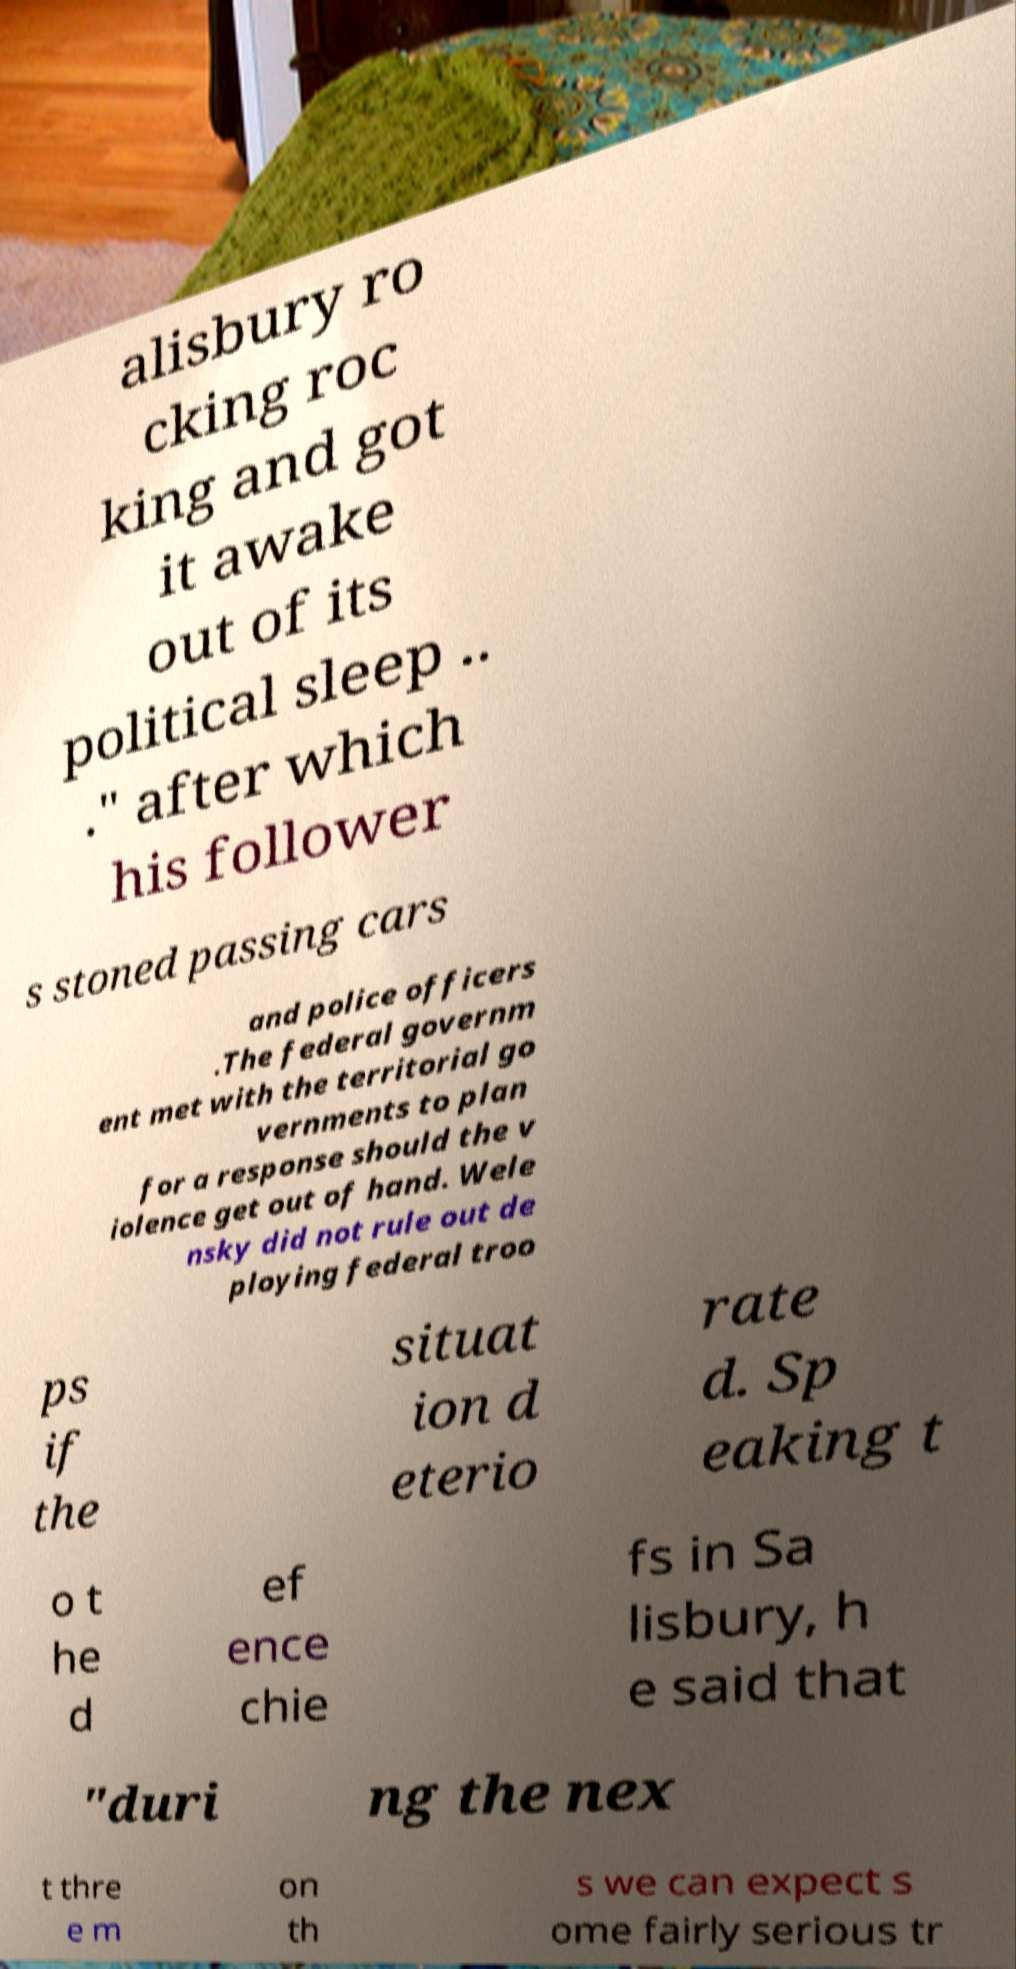Please read and relay the text visible in this image. What does it say? alisbury ro cking roc king and got it awake out of its political sleep .. ." after which his follower s stoned passing cars and police officers .The federal governm ent met with the territorial go vernments to plan for a response should the v iolence get out of hand. Wele nsky did not rule out de ploying federal troo ps if the situat ion d eterio rate d. Sp eaking t o t he d ef ence chie fs in Sa lisbury, h e said that "duri ng the nex t thre e m on th s we can expect s ome fairly serious tr 